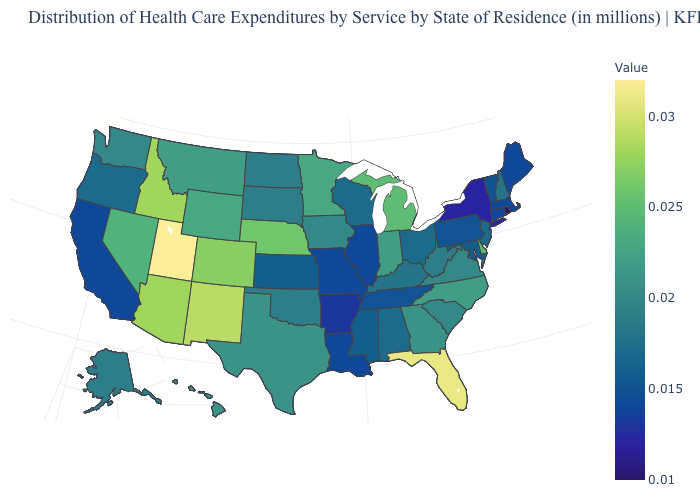Does Nebraska have the highest value in the MidWest?
Give a very brief answer. Yes. Does North Carolina have the highest value in the South?
Short answer required. No. Among the states that border South Dakota , which have the lowest value?
Quick response, please. North Dakota. Does the map have missing data?
Short answer required. No. 